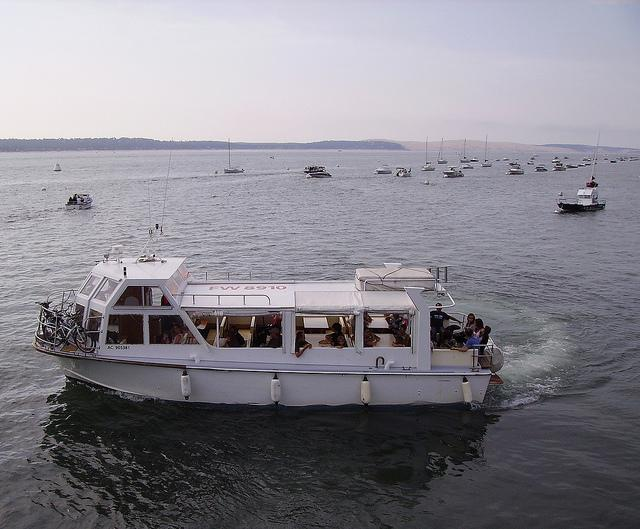What vehicle is stored in front of the boat?

Choices:
A) raft
B) quad
C) sedan
D) bike bike 